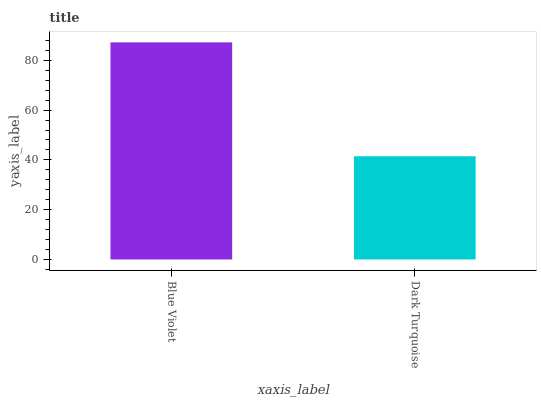Is Dark Turquoise the minimum?
Answer yes or no. Yes. Is Blue Violet the maximum?
Answer yes or no. Yes. Is Dark Turquoise the maximum?
Answer yes or no. No. Is Blue Violet greater than Dark Turquoise?
Answer yes or no. Yes. Is Dark Turquoise less than Blue Violet?
Answer yes or no. Yes. Is Dark Turquoise greater than Blue Violet?
Answer yes or no. No. Is Blue Violet less than Dark Turquoise?
Answer yes or no. No. Is Blue Violet the high median?
Answer yes or no. Yes. Is Dark Turquoise the low median?
Answer yes or no. Yes. Is Dark Turquoise the high median?
Answer yes or no. No. Is Blue Violet the low median?
Answer yes or no. No. 